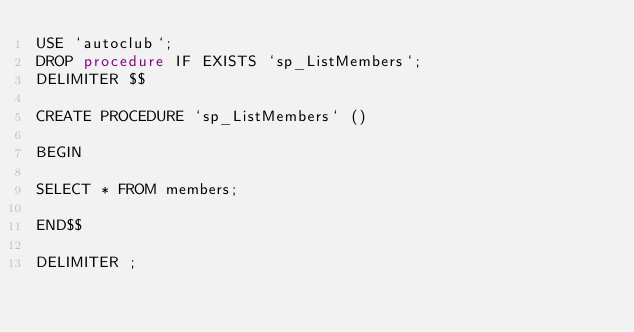Convert code to text. <code><loc_0><loc_0><loc_500><loc_500><_SQL_>USE `autoclub`;
DROP procedure IF EXISTS `sp_ListMembers`;
DELIMITER $$

CREATE PROCEDURE `sp_ListMembers` ()

BEGIN

SELECT * FROM members;

END$$

DELIMITER ;
</code> 